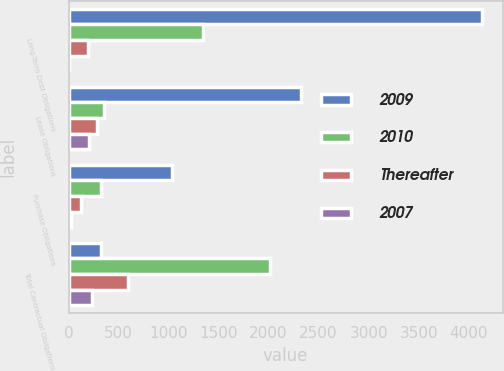<chart> <loc_0><loc_0><loc_500><loc_500><stacked_bar_chart><ecel><fcel>Long-Term Debt Obligations<fcel>Lease Obligations<fcel>Purchase Obligations<fcel>Total Contractual Obligations<nl><fcel>2009<fcel>4134<fcel>2328<fcel>1035<fcel>326<nl><fcel>2010<fcel>1340<fcel>351<fcel>326<fcel>2017<nl><fcel>Thereafter<fcel>198<fcel>281<fcel>120<fcel>599<nl><fcel>2007<fcel>4<fcel>209<fcel>26<fcel>239<nl></chart> 